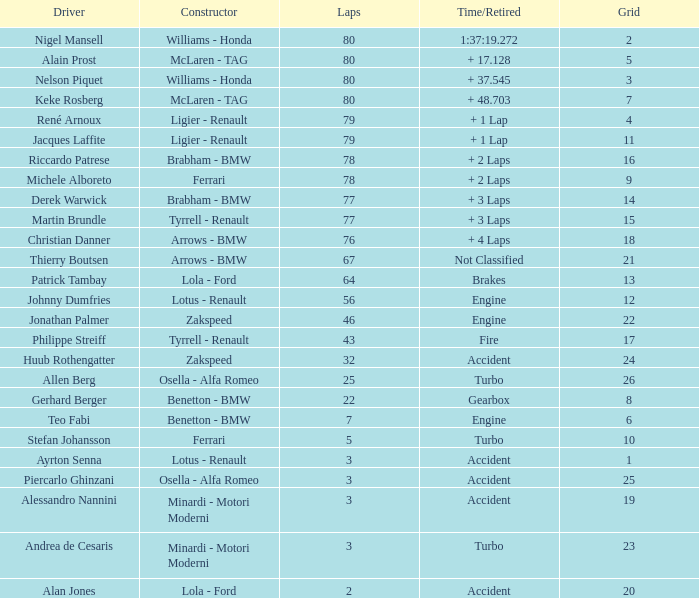At what time did thierry boutsen end his career? Not Classified. 